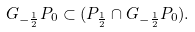Convert formula to latex. <formula><loc_0><loc_0><loc_500><loc_500>G _ { - \frac { 1 } { 2 } } P _ { 0 } \subset ( P _ { \frac { 1 } { 2 } } \cap G _ { - \frac { 1 } { 2 } } P _ { 0 } ) .</formula> 